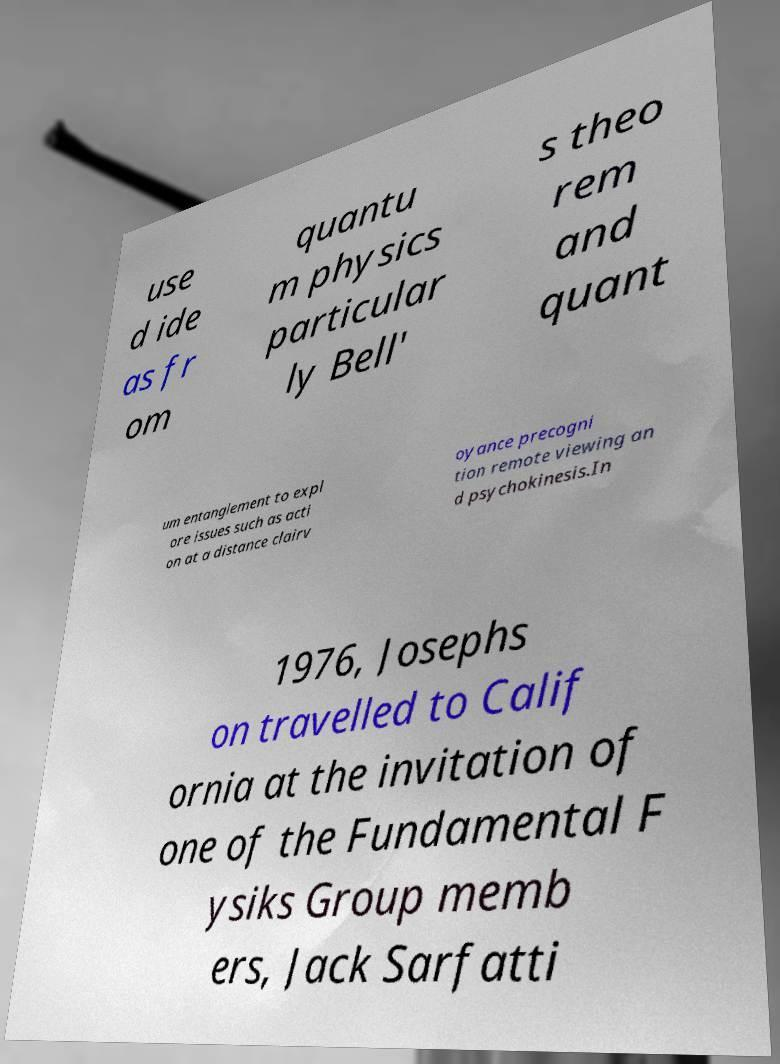Could you assist in decoding the text presented in this image and type it out clearly? use d ide as fr om quantu m physics particular ly Bell' s theo rem and quant um entanglement to expl ore issues such as acti on at a distance clairv oyance precogni tion remote viewing an d psychokinesis.In 1976, Josephs on travelled to Calif ornia at the invitation of one of the Fundamental F ysiks Group memb ers, Jack Sarfatti 